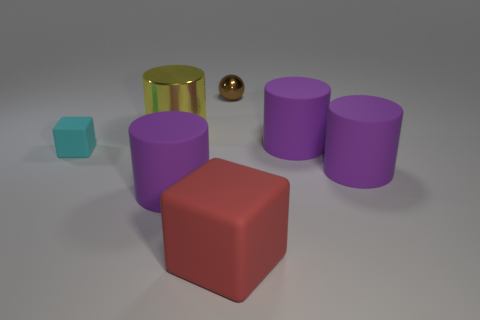What number of other things are there of the same material as the big block
Keep it short and to the point. 4. There is a yellow shiny thing; does it have the same size as the purple cylinder behind the tiny cyan object?
Offer a terse response. Yes. Are there fewer metallic cylinders that are left of the yellow cylinder than large rubber cylinders behind the ball?
Your answer should be compact. No. What size is the purple object to the left of the small shiny thing?
Your answer should be very brief. Large. Is the yellow metallic cylinder the same size as the red rubber object?
Give a very brief answer. Yes. What number of things are to the right of the yellow metallic cylinder and in front of the large yellow cylinder?
Your response must be concise. 4. What number of red objects are either large rubber cubes or rubber blocks?
Ensure brevity in your answer.  1. What number of metal things are either big gray cubes or small things?
Offer a terse response. 1. Are any small brown metal balls visible?
Offer a very short reply. Yes. Is the shape of the large yellow object the same as the small brown thing?
Ensure brevity in your answer.  No. 